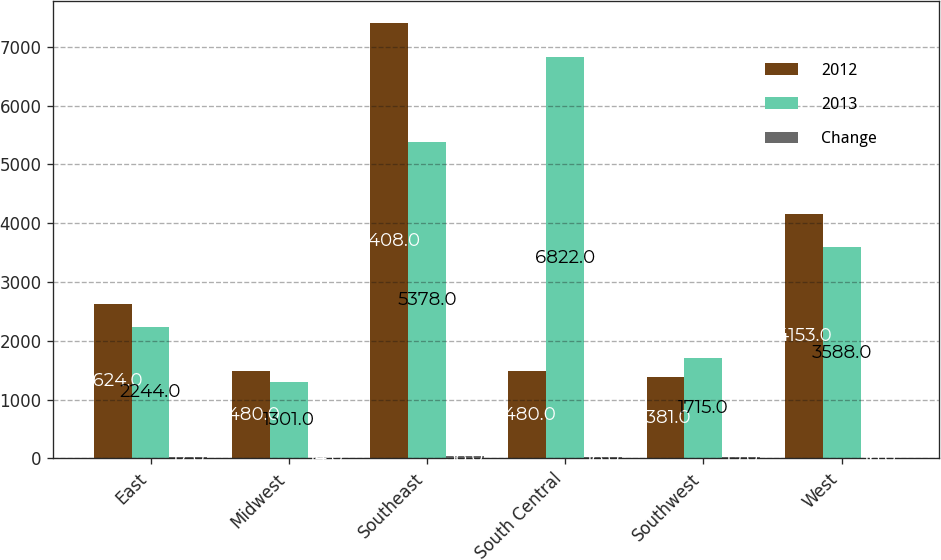Convert chart. <chart><loc_0><loc_0><loc_500><loc_500><stacked_bar_chart><ecel><fcel>East<fcel>Midwest<fcel>Southeast<fcel>South Central<fcel>Southwest<fcel>West<nl><fcel>2012<fcel>2624<fcel>1480<fcel>7408<fcel>1480<fcel>1381<fcel>4153<nl><fcel>2013<fcel>2244<fcel>1301<fcel>5378<fcel>6822<fcel>1715<fcel>3588<nl><fcel>Change<fcel>17<fcel>14<fcel>38<fcel>18<fcel>19<fcel>16<nl></chart> 